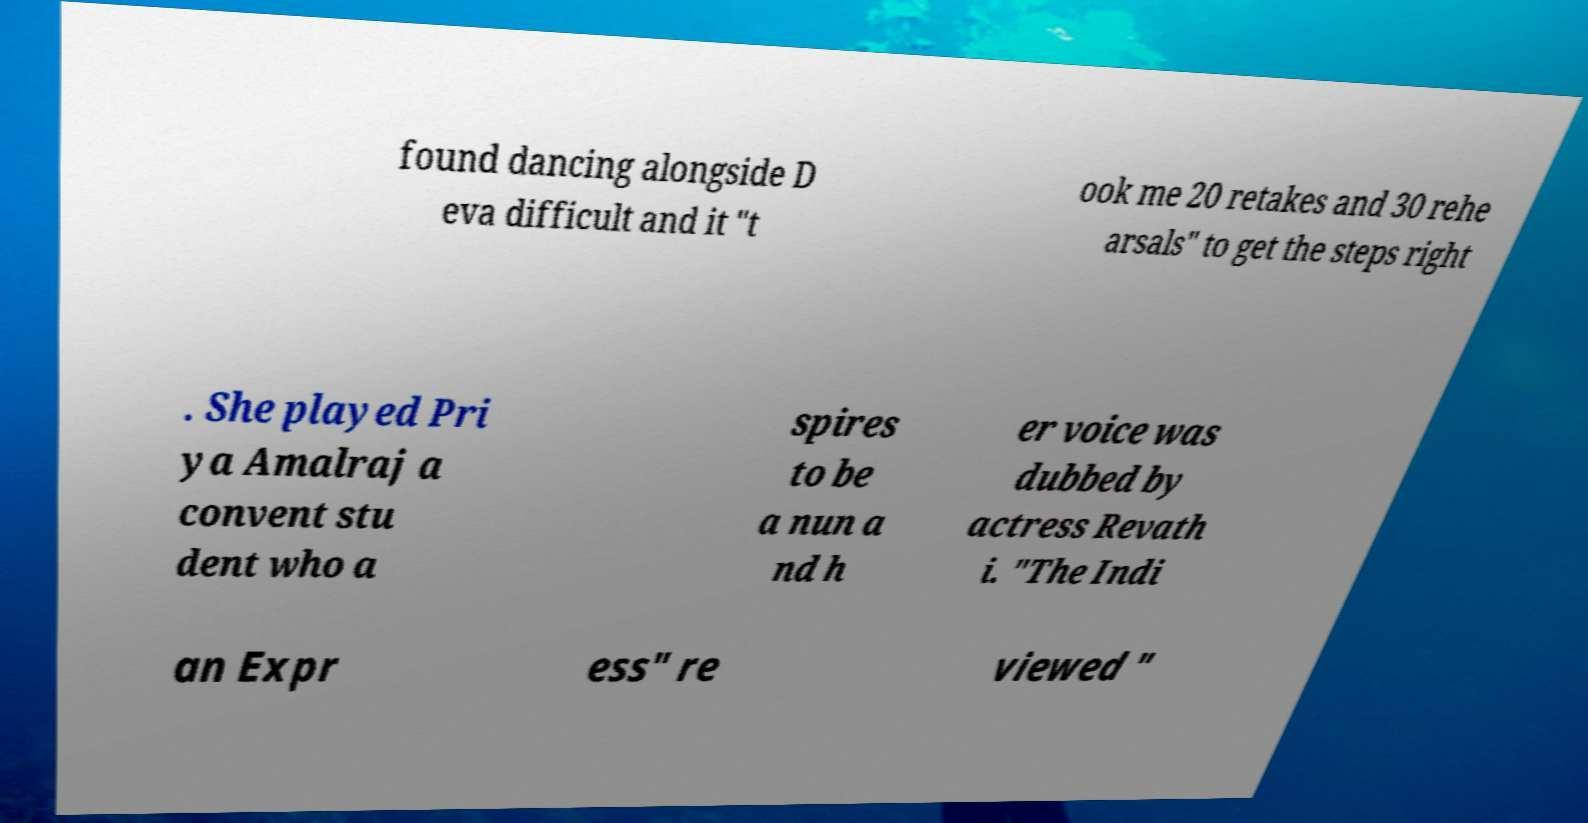There's text embedded in this image that I need extracted. Can you transcribe it verbatim? found dancing alongside D eva difficult and it "t ook me 20 retakes and 30 rehe arsals" to get the steps right . She played Pri ya Amalraj a convent stu dent who a spires to be a nun a nd h er voice was dubbed by actress Revath i. "The Indi an Expr ess" re viewed " 